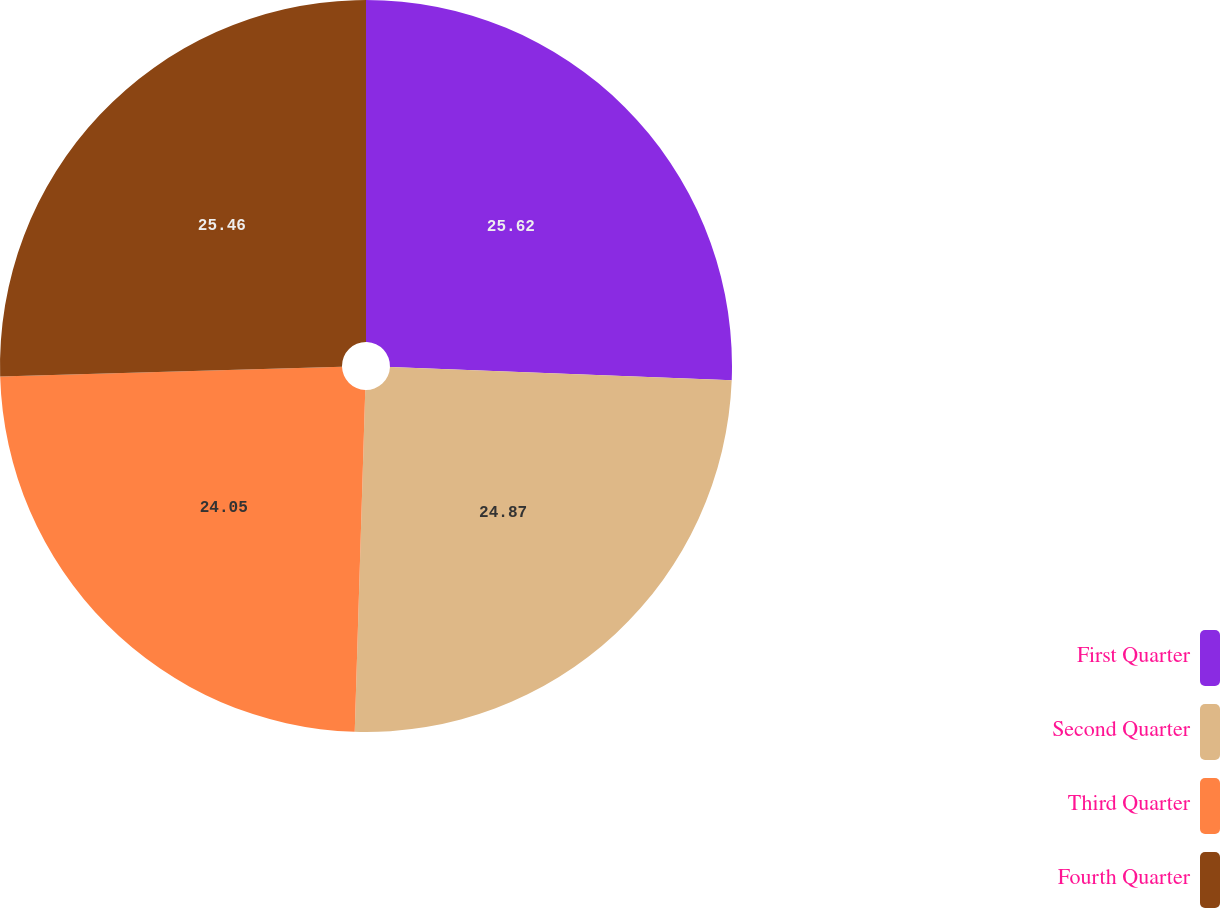Convert chart to OTSL. <chart><loc_0><loc_0><loc_500><loc_500><pie_chart><fcel>First Quarter<fcel>Second Quarter<fcel>Third Quarter<fcel>Fourth Quarter<nl><fcel>25.62%<fcel>24.87%<fcel>24.05%<fcel>25.46%<nl></chart> 